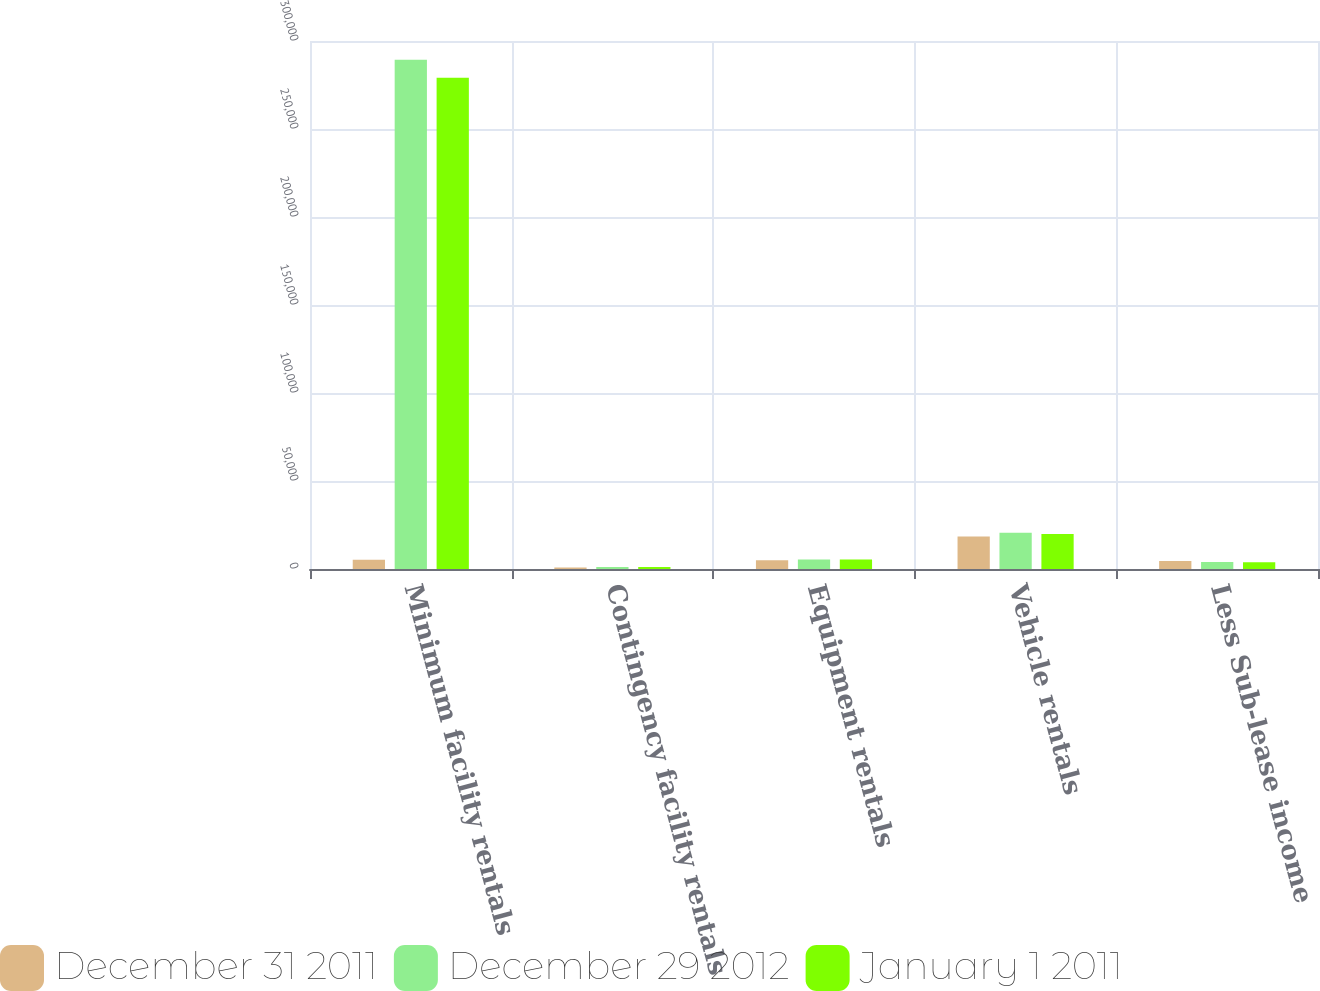Convert chart. <chart><loc_0><loc_0><loc_500><loc_500><stacked_bar_chart><ecel><fcel>Minimum facility rentals<fcel>Contingency facility rentals<fcel>Equipment rentals<fcel>Vehicle rentals<fcel>Less Sub-lease income<nl><fcel>December 31 2011<fcel>5201<fcel>907<fcel>5027<fcel>18401<fcel>4600<nl><fcel>December 29 2012<fcel>289306<fcel>1162<fcel>5403<fcel>20565<fcel>3967<nl><fcel>January 1 2011<fcel>279099<fcel>1115<fcel>5375<fcel>19903<fcel>3813<nl></chart> 